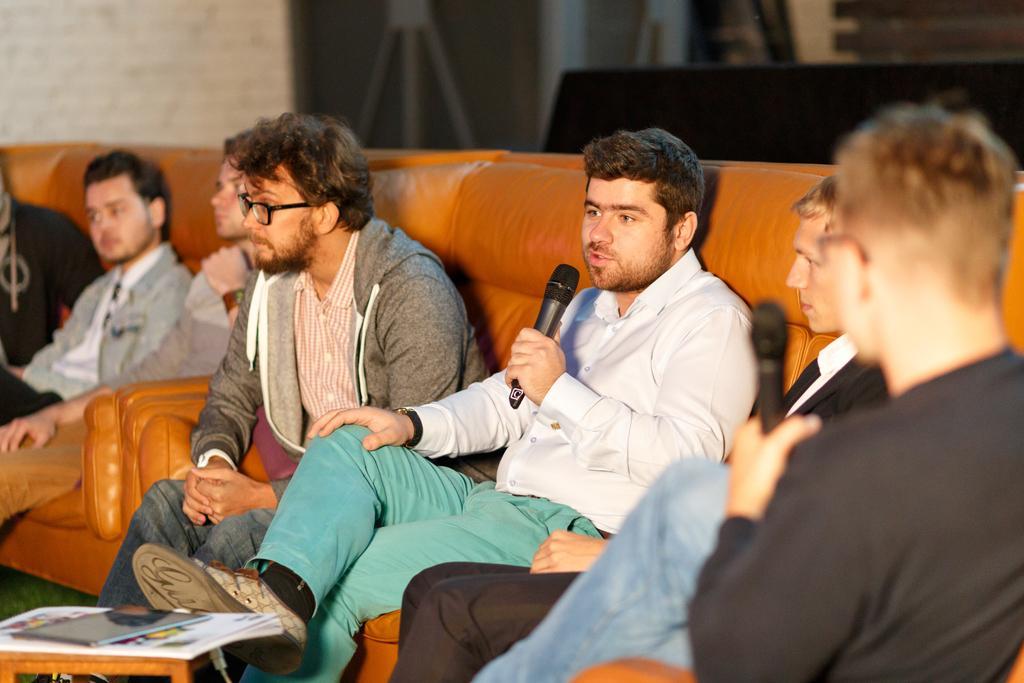Describe this image in one or two sentences. In this picture, There is a sofa which is in yellow color on that sofa there are some people sitting and holding the microphones which are in black color, In the background there is a white color wall. 